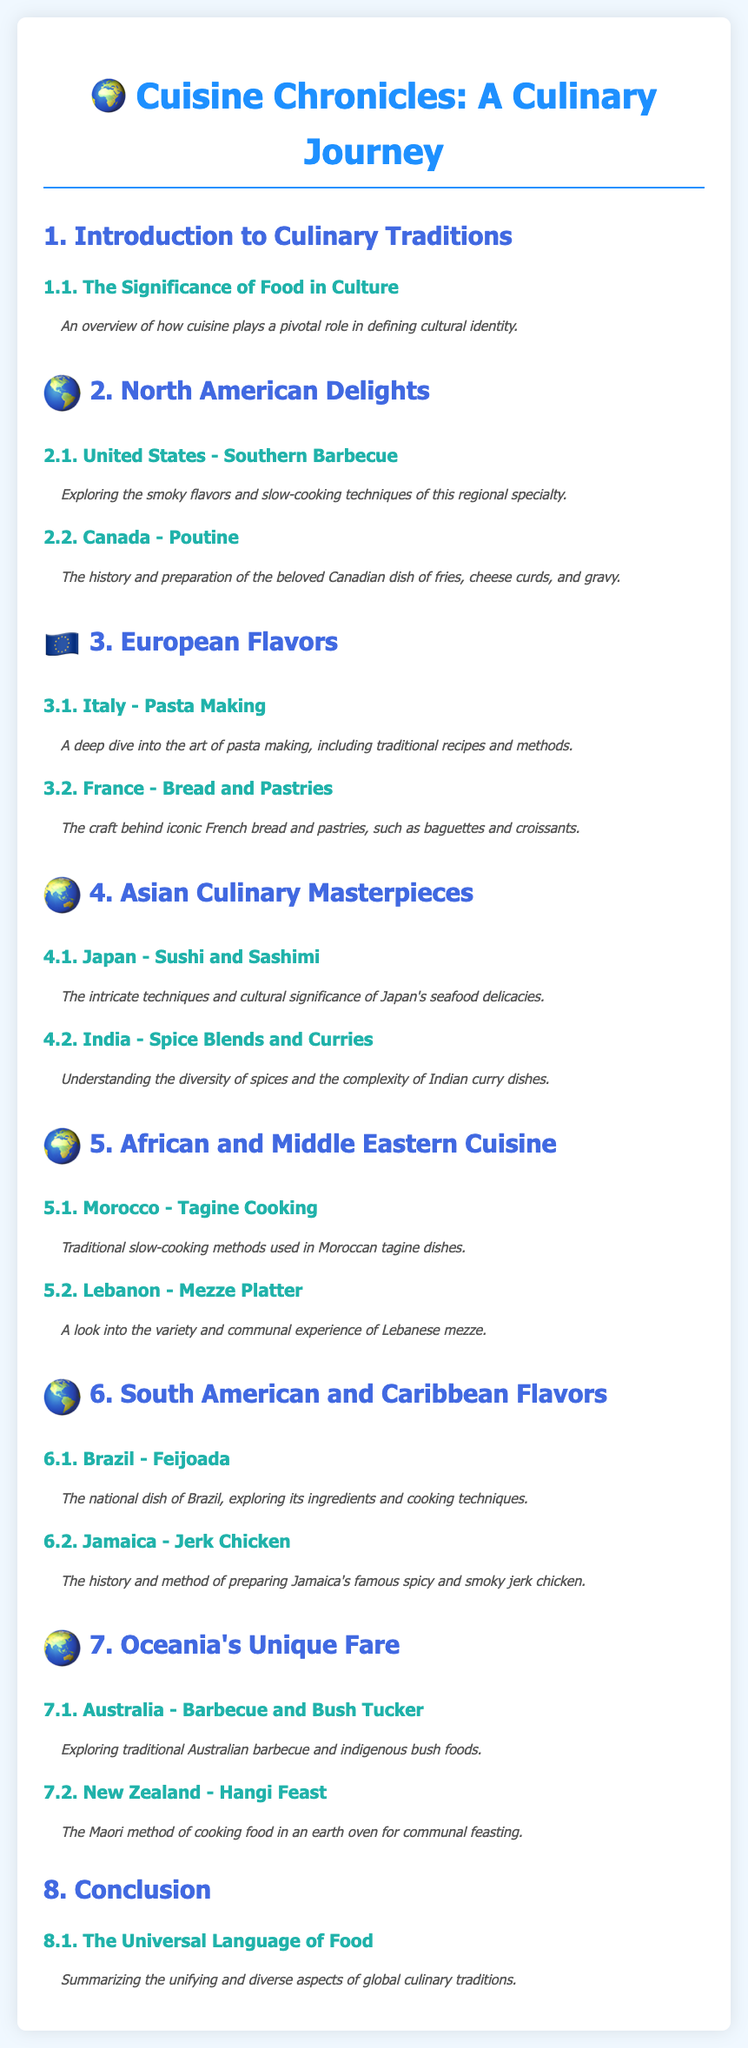What is the title of the document? The title of the document is prominently displayed at the top and summarizes its content.
Answer: Cuisine Chronicles: A Culinary Journey What is covered in section 2.1? Section 2.1 highlights the specifics of a regional specialty, emphasizing flavors and techniques.
Answer: Southern Barbecue What food is associated with Canada in section 2.2? Section 2.2 discusses a popular Canadian dish and its key components.
Answer: Poutine What is the focus of section 3.2? This section reveals the craft involved in creating a specific type of baked good.
Answer: Bread and Pastries Which country is featured under section 4.1? Section 4.1 specifically explores seafood delicacies from a well-known Asian country.
Answer: Japan What cooking method is highlighted in section 5.1? Section 5.1 describes a traditional slow-cooking technique used in Moroccan cuisine.
Answer: Tagine Cooking How many regions are discussed in the document? The document outlines distinct culinary traditions across various geographical areas.
Answer: Seven What is the theme of the conclusion section? The conclusion summarizes the overarching message about food and its cultural relevance.
Answer: The Universal Language of Food 